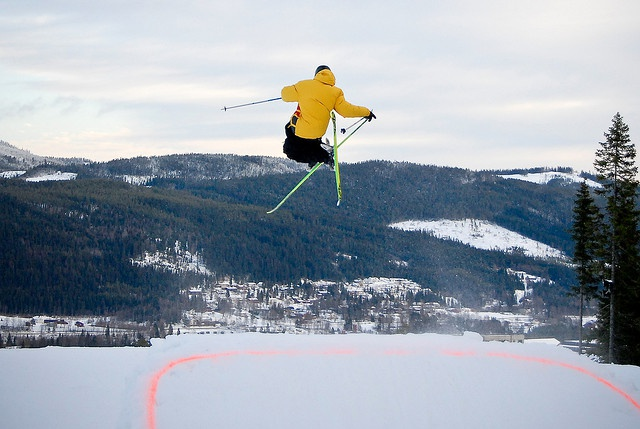Describe the objects in this image and their specific colors. I can see people in lightgray, orange, black, white, and tan tones and skis in lightgray, lightgreen, ivory, khaki, and teal tones in this image. 